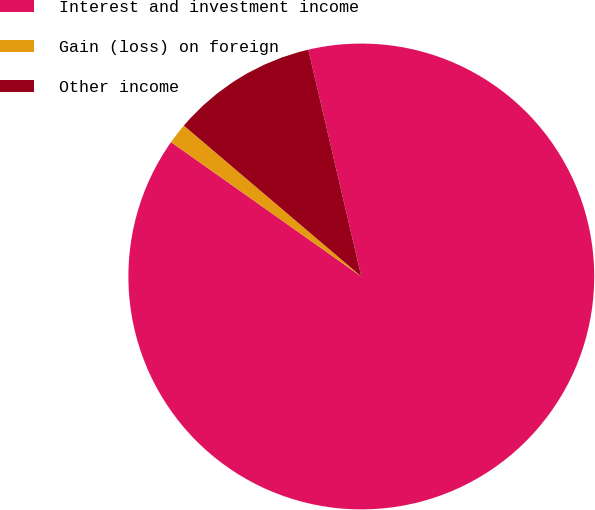Convert chart. <chart><loc_0><loc_0><loc_500><loc_500><pie_chart><fcel>Interest and investment income<fcel>Gain (loss) on foreign<fcel>Other income<nl><fcel>88.45%<fcel>1.43%<fcel>10.13%<nl></chart> 